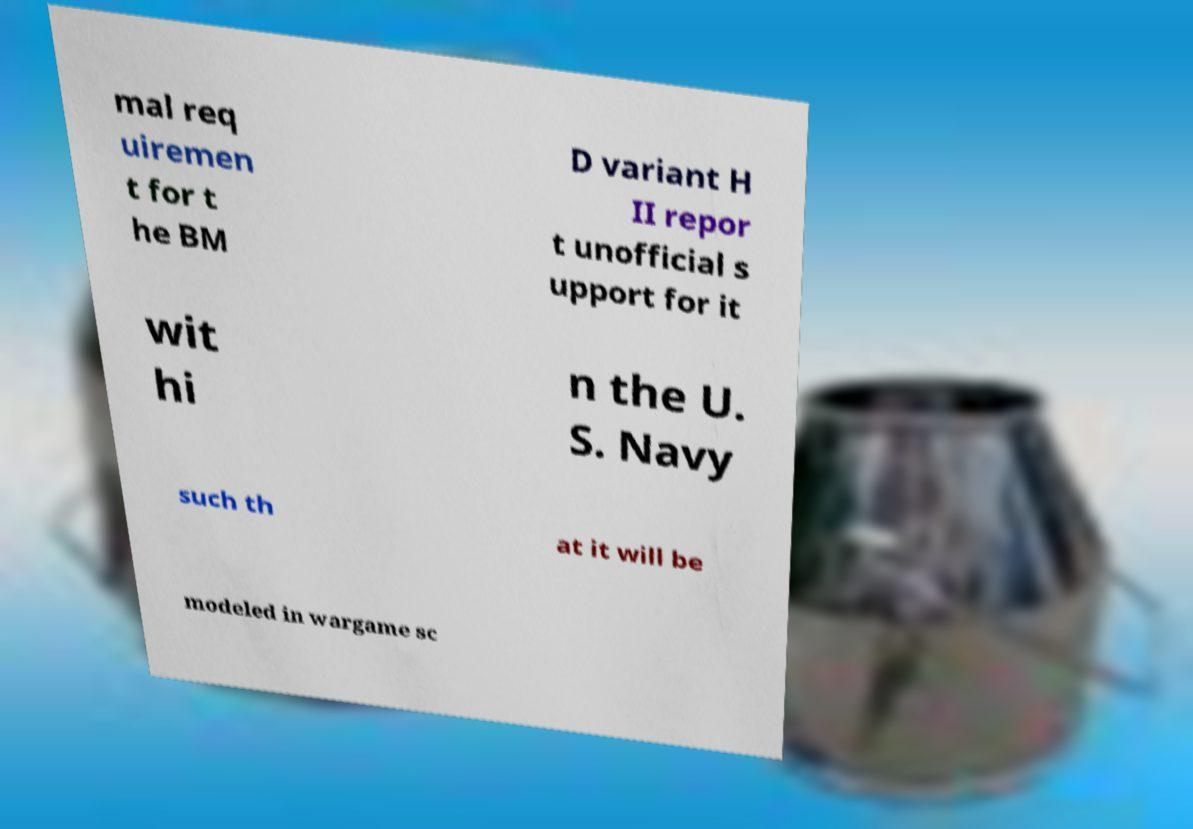There's text embedded in this image that I need extracted. Can you transcribe it verbatim? mal req uiremen t for t he BM D variant H II repor t unofficial s upport for it wit hi n the U. S. Navy such th at it will be modeled in wargame sc 